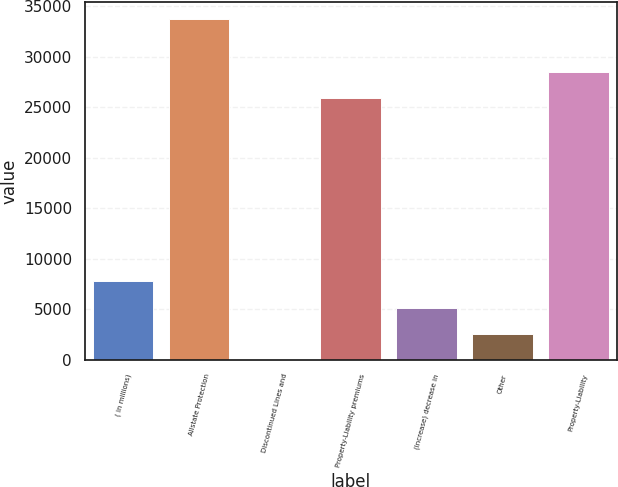Convert chart. <chart><loc_0><loc_0><loc_500><loc_500><bar_chart><fcel>( in millions)<fcel>Allstate Protection<fcel>Discontinued Lines and<fcel>Property-Liability premiums<fcel>(Increase) decrease in<fcel>Other<fcel>Property-Liability<nl><fcel>7795<fcel>33736<fcel>1<fcel>25942<fcel>5197<fcel>2599<fcel>28540<nl></chart> 